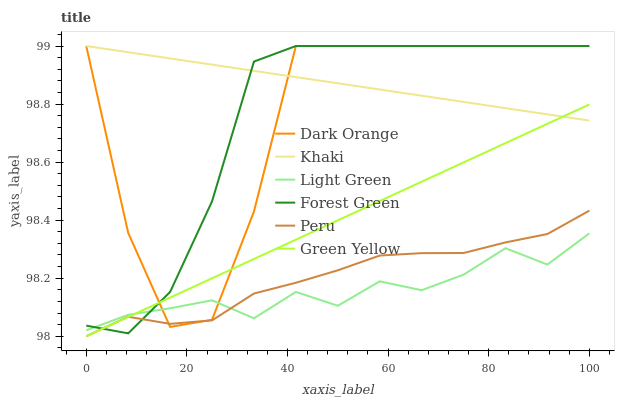Does Light Green have the minimum area under the curve?
Answer yes or no. Yes. Does Khaki have the maximum area under the curve?
Answer yes or no. Yes. Does Khaki have the minimum area under the curve?
Answer yes or no. No. Does Light Green have the maximum area under the curve?
Answer yes or no. No. Is Green Yellow the smoothest?
Answer yes or no. Yes. Is Dark Orange the roughest?
Answer yes or no. Yes. Is Khaki the smoothest?
Answer yes or no. No. Is Khaki the roughest?
Answer yes or no. No. Does Peru have the lowest value?
Answer yes or no. Yes. Does Light Green have the lowest value?
Answer yes or no. No. Does Forest Green have the highest value?
Answer yes or no. Yes. Does Light Green have the highest value?
Answer yes or no. No. Is Peru less than Khaki?
Answer yes or no. Yes. Is Khaki greater than Light Green?
Answer yes or no. Yes. Does Green Yellow intersect Peru?
Answer yes or no. Yes. Is Green Yellow less than Peru?
Answer yes or no. No. Is Green Yellow greater than Peru?
Answer yes or no. No. Does Peru intersect Khaki?
Answer yes or no. No. 